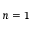Convert formula to latex. <formula><loc_0><loc_0><loc_500><loc_500>n = 1</formula> 